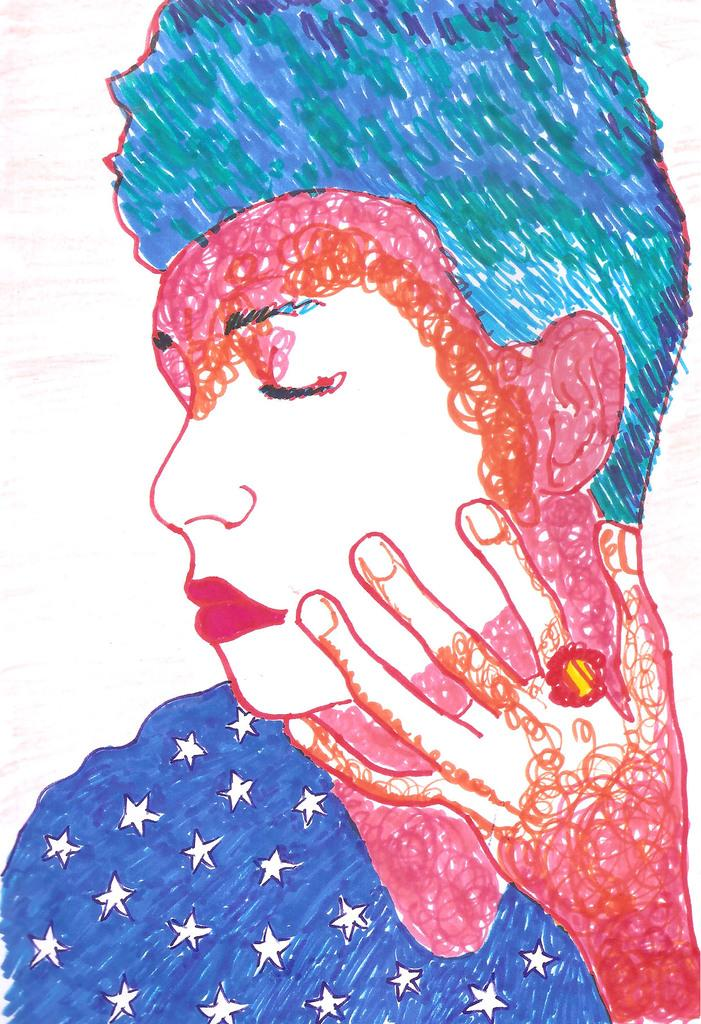What is the main subject of the image? There is an art piece in the image. What does the art piece depict? The art piece depicts a person. What color is the background of the image? The background of the image is white. What type of mark can be seen on the person's forehead in the image? There is no mark visible on the person's forehead in the image. How does the cabbage relate to the art piece in the image? There is no cabbage present in the image, so it cannot be related to the art piece. 